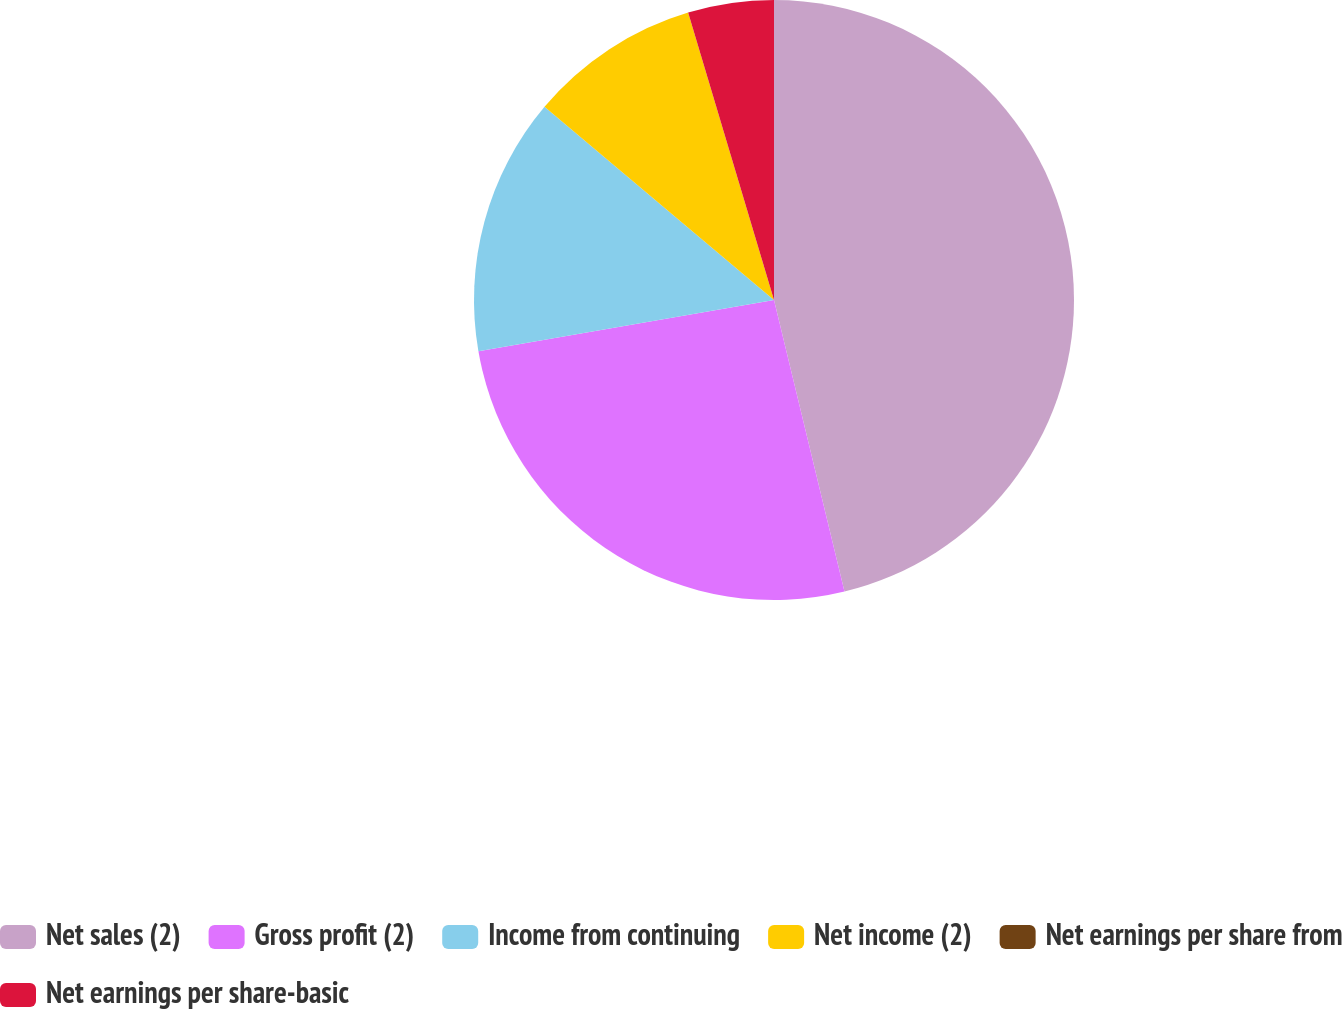Convert chart. <chart><loc_0><loc_0><loc_500><loc_500><pie_chart><fcel>Net sales (2)<fcel>Gross profit (2)<fcel>Income from continuing<fcel>Net income (2)<fcel>Net earnings per share from<fcel>Net earnings per share-basic<nl><fcel>46.22%<fcel>26.04%<fcel>13.87%<fcel>9.24%<fcel>0.0%<fcel>4.62%<nl></chart> 